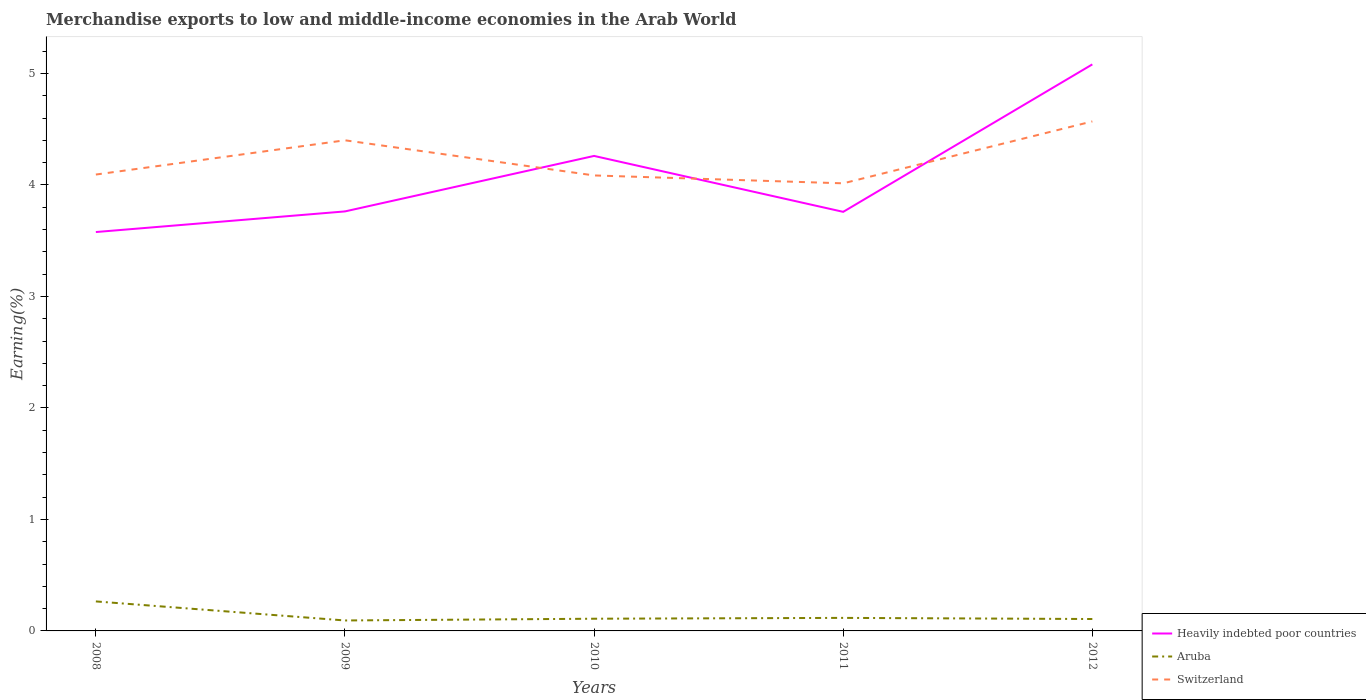How many different coloured lines are there?
Your response must be concise. 3. Is the number of lines equal to the number of legend labels?
Make the answer very short. Yes. Across all years, what is the maximum percentage of amount earned from merchandise exports in Switzerland?
Provide a succinct answer. 4.01. In which year was the percentage of amount earned from merchandise exports in Switzerland maximum?
Ensure brevity in your answer.  2011. What is the total percentage of amount earned from merchandise exports in Aruba in the graph?
Provide a succinct answer. -0.01. What is the difference between the highest and the second highest percentage of amount earned from merchandise exports in Heavily indebted poor countries?
Provide a succinct answer. 1.5. What is the difference between the highest and the lowest percentage of amount earned from merchandise exports in Heavily indebted poor countries?
Offer a terse response. 2. Is the percentage of amount earned from merchandise exports in Switzerland strictly greater than the percentage of amount earned from merchandise exports in Heavily indebted poor countries over the years?
Provide a short and direct response. No. How many lines are there?
Your response must be concise. 3. How many years are there in the graph?
Offer a terse response. 5. What is the difference between two consecutive major ticks on the Y-axis?
Offer a very short reply. 1. Where does the legend appear in the graph?
Provide a succinct answer. Bottom right. How many legend labels are there?
Provide a short and direct response. 3. What is the title of the graph?
Make the answer very short. Merchandise exports to low and middle-income economies in the Arab World. What is the label or title of the Y-axis?
Ensure brevity in your answer.  Earning(%). What is the Earning(%) of Heavily indebted poor countries in 2008?
Offer a very short reply. 3.58. What is the Earning(%) in Aruba in 2008?
Provide a succinct answer. 0.26. What is the Earning(%) in Switzerland in 2008?
Your answer should be very brief. 4.09. What is the Earning(%) in Heavily indebted poor countries in 2009?
Offer a terse response. 3.76. What is the Earning(%) in Aruba in 2009?
Ensure brevity in your answer.  0.09. What is the Earning(%) of Switzerland in 2009?
Provide a short and direct response. 4.4. What is the Earning(%) in Heavily indebted poor countries in 2010?
Your answer should be very brief. 4.26. What is the Earning(%) of Aruba in 2010?
Give a very brief answer. 0.11. What is the Earning(%) in Switzerland in 2010?
Give a very brief answer. 4.09. What is the Earning(%) of Heavily indebted poor countries in 2011?
Keep it short and to the point. 3.76. What is the Earning(%) in Aruba in 2011?
Give a very brief answer. 0.12. What is the Earning(%) of Switzerland in 2011?
Your response must be concise. 4.01. What is the Earning(%) in Heavily indebted poor countries in 2012?
Provide a short and direct response. 5.08. What is the Earning(%) of Aruba in 2012?
Your answer should be compact. 0.11. What is the Earning(%) in Switzerland in 2012?
Give a very brief answer. 4.57. Across all years, what is the maximum Earning(%) in Heavily indebted poor countries?
Give a very brief answer. 5.08. Across all years, what is the maximum Earning(%) of Aruba?
Provide a short and direct response. 0.26. Across all years, what is the maximum Earning(%) in Switzerland?
Give a very brief answer. 4.57. Across all years, what is the minimum Earning(%) in Heavily indebted poor countries?
Provide a short and direct response. 3.58. Across all years, what is the minimum Earning(%) in Aruba?
Your answer should be compact. 0.09. Across all years, what is the minimum Earning(%) in Switzerland?
Offer a very short reply. 4.01. What is the total Earning(%) of Heavily indebted poor countries in the graph?
Your response must be concise. 20.44. What is the total Earning(%) of Aruba in the graph?
Ensure brevity in your answer.  0.69. What is the total Earning(%) in Switzerland in the graph?
Ensure brevity in your answer.  21.16. What is the difference between the Earning(%) in Heavily indebted poor countries in 2008 and that in 2009?
Keep it short and to the point. -0.18. What is the difference between the Earning(%) in Aruba in 2008 and that in 2009?
Your answer should be compact. 0.17. What is the difference between the Earning(%) in Switzerland in 2008 and that in 2009?
Provide a short and direct response. -0.31. What is the difference between the Earning(%) in Heavily indebted poor countries in 2008 and that in 2010?
Provide a short and direct response. -0.68. What is the difference between the Earning(%) of Aruba in 2008 and that in 2010?
Your response must be concise. 0.16. What is the difference between the Earning(%) in Switzerland in 2008 and that in 2010?
Give a very brief answer. 0.01. What is the difference between the Earning(%) of Heavily indebted poor countries in 2008 and that in 2011?
Your answer should be compact. -0.18. What is the difference between the Earning(%) in Aruba in 2008 and that in 2011?
Your answer should be compact. 0.15. What is the difference between the Earning(%) of Switzerland in 2008 and that in 2011?
Your response must be concise. 0.08. What is the difference between the Earning(%) of Heavily indebted poor countries in 2008 and that in 2012?
Offer a terse response. -1.5. What is the difference between the Earning(%) of Aruba in 2008 and that in 2012?
Ensure brevity in your answer.  0.16. What is the difference between the Earning(%) in Switzerland in 2008 and that in 2012?
Offer a terse response. -0.48. What is the difference between the Earning(%) of Heavily indebted poor countries in 2009 and that in 2010?
Offer a terse response. -0.5. What is the difference between the Earning(%) in Aruba in 2009 and that in 2010?
Ensure brevity in your answer.  -0.02. What is the difference between the Earning(%) in Switzerland in 2009 and that in 2010?
Keep it short and to the point. 0.32. What is the difference between the Earning(%) in Heavily indebted poor countries in 2009 and that in 2011?
Offer a terse response. 0. What is the difference between the Earning(%) in Aruba in 2009 and that in 2011?
Ensure brevity in your answer.  -0.02. What is the difference between the Earning(%) in Switzerland in 2009 and that in 2011?
Give a very brief answer. 0.39. What is the difference between the Earning(%) in Heavily indebted poor countries in 2009 and that in 2012?
Offer a very short reply. -1.32. What is the difference between the Earning(%) of Aruba in 2009 and that in 2012?
Offer a terse response. -0.01. What is the difference between the Earning(%) of Switzerland in 2009 and that in 2012?
Offer a terse response. -0.17. What is the difference between the Earning(%) in Heavily indebted poor countries in 2010 and that in 2011?
Offer a terse response. 0.5. What is the difference between the Earning(%) of Aruba in 2010 and that in 2011?
Provide a succinct answer. -0.01. What is the difference between the Earning(%) in Switzerland in 2010 and that in 2011?
Give a very brief answer. 0.07. What is the difference between the Earning(%) of Heavily indebted poor countries in 2010 and that in 2012?
Offer a terse response. -0.82. What is the difference between the Earning(%) in Aruba in 2010 and that in 2012?
Give a very brief answer. 0. What is the difference between the Earning(%) of Switzerland in 2010 and that in 2012?
Your answer should be very brief. -0.48. What is the difference between the Earning(%) of Heavily indebted poor countries in 2011 and that in 2012?
Provide a succinct answer. -1.32. What is the difference between the Earning(%) of Aruba in 2011 and that in 2012?
Keep it short and to the point. 0.01. What is the difference between the Earning(%) in Switzerland in 2011 and that in 2012?
Your answer should be very brief. -0.56. What is the difference between the Earning(%) in Heavily indebted poor countries in 2008 and the Earning(%) in Aruba in 2009?
Provide a succinct answer. 3.48. What is the difference between the Earning(%) of Heavily indebted poor countries in 2008 and the Earning(%) of Switzerland in 2009?
Provide a short and direct response. -0.82. What is the difference between the Earning(%) in Aruba in 2008 and the Earning(%) in Switzerland in 2009?
Your response must be concise. -4.14. What is the difference between the Earning(%) of Heavily indebted poor countries in 2008 and the Earning(%) of Aruba in 2010?
Offer a very short reply. 3.47. What is the difference between the Earning(%) in Heavily indebted poor countries in 2008 and the Earning(%) in Switzerland in 2010?
Provide a succinct answer. -0.51. What is the difference between the Earning(%) of Aruba in 2008 and the Earning(%) of Switzerland in 2010?
Provide a succinct answer. -3.82. What is the difference between the Earning(%) of Heavily indebted poor countries in 2008 and the Earning(%) of Aruba in 2011?
Keep it short and to the point. 3.46. What is the difference between the Earning(%) in Heavily indebted poor countries in 2008 and the Earning(%) in Switzerland in 2011?
Offer a very short reply. -0.44. What is the difference between the Earning(%) of Aruba in 2008 and the Earning(%) of Switzerland in 2011?
Provide a succinct answer. -3.75. What is the difference between the Earning(%) in Heavily indebted poor countries in 2008 and the Earning(%) in Aruba in 2012?
Your response must be concise. 3.47. What is the difference between the Earning(%) in Heavily indebted poor countries in 2008 and the Earning(%) in Switzerland in 2012?
Keep it short and to the point. -0.99. What is the difference between the Earning(%) in Aruba in 2008 and the Earning(%) in Switzerland in 2012?
Provide a succinct answer. -4.3. What is the difference between the Earning(%) of Heavily indebted poor countries in 2009 and the Earning(%) of Aruba in 2010?
Provide a succinct answer. 3.65. What is the difference between the Earning(%) in Heavily indebted poor countries in 2009 and the Earning(%) in Switzerland in 2010?
Your response must be concise. -0.32. What is the difference between the Earning(%) of Aruba in 2009 and the Earning(%) of Switzerland in 2010?
Provide a succinct answer. -3.99. What is the difference between the Earning(%) in Heavily indebted poor countries in 2009 and the Earning(%) in Aruba in 2011?
Your answer should be very brief. 3.65. What is the difference between the Earning(%) in Heavily indebted poor countries in 2009 and the Earning(%) in Switzerland in 2011?
Ensure brevity in your answer.  -0.25. What is the difference between the Earning(%) of Aruba in 2009 and the Earning(%) of Switzerland in 2011?
Ensure brevity in your answer.  -3.92. What is the difference between the Earning(%) of Heavily indebted poor countries in 2009 and the Earning(%) of Aruba in 2012?
Your response must be concise. 3.66. What is the difference between the Earning(%) in Heavily indebted poor countries in 2009 and the Earning(%) in Switzerland in 2012?
Your answer should be very brief. -0.81. What is the difference between the Earning(%) in Aruba in 2009 and the Earning(%) in Switzerland in 2012?
Provide a succinct answer. -4.48. What is the difference between the Earning(%) of Heavily indebted poor countries in 2010 and the Earning(%) of Aruba in 2011?
Your answer should be compact. 4.14. What is the difference between the Earning(%) of Heavily indebted poor countries in 2010 and the Earning(%) of Switzerland in 2011?
Your answer should be very brief. 0.25. What is the difference between the Earning(%) in Aruba in 2010 and the Earning(%) in Switzerland in 2011?
Ensure brevity in your answer.  -3.9. What is the difference between the Earning(%) of Heavily indebted poor countries in 2010 and the Earning(%) of Aruba in 2012?
Make the answer very short. 4.15. What is the difference between the Earning(%) of Heavily indebted poor countries in 2010 and the Earning(%) of Switzerland in 2012?
Your answer should be very brief. -0.31. What is the difference between the Earning(%) in Aruba in 2010 and the Earning(%) in Switzerland in 2012?
Make the answer very short. -4.46. What is the difference between the Earning(%) of Heavily indebted poor countries in 2011 and the Earning(%) of Aruba in 2012?
Your answer should be very brief. 3.65. What is the difference between the Earning(%) in Heavily indebted poor countries in 2011 and the Earning(%) in Switzerland in 2012?
Offer a terse response. -0.81. What is the difference between the Earning(%) in Aruba in 2011 and the Earning(%) in Switzerland in 2012?
Your response must be concise. -4.45. What is the average Earning(%) of Heavily indebted poor countries per year?
Ensure brevity in your answer.  4.09. What is the average Earning(%) in Aruba per year?
Give a very brief answer. 0.14. What is the average Earning(%) in Switzerland per year?
Make the answer very short. 4.23. In the year 2008, what is the difference between the Earning(%) of Heavily indebted poor countries and Earning(%) of Aruba?
Keep it short and to the point. 3.31. In the year 2008, what is the difference between the Earning(%) of Heavily indebted poor countries and Earning(%) of Switzerland?
Provide a short and direct response. -0.52. In the year 2008, what is the difference between the Earning(%) of Aruba and Earning(%) of Switzerland?
Your answer should be compact. -3.83. In the year 2009, what is the difference between the Earning(%) in Heavily indebted poor countries and Earning(%) in Aruba?
Provide a succinct answer. 3.67. In the year 2009, what is the difference between the Earning(%) of Heavily indebted poor countries and Earning(%) of Switzerland?
Keep it short and to the point. -0.64. In the year 2009, what is the difference between the Earning(%) of Aruba and Earning(%) of Switzerland?
Your answer should be compact. -4.31. In the year 2010, what is the difference between the Earning(%) of Heavily indebted poor countries and Earning(%) of Aruba?
Give a very brief answer. 4.15. In the year 2010, what is the difference between the Earning(%) in Heavily indebted poor countries and Earning(%) in Switzerland?
Your answer should be very brief. 0.17. In the year 2010, what is the difference between the Earning(%) in Aruba and Earning(%) in Switzerland?
Ensure brevity in your answer.  -3.98. In the year 2011, what is the difference between the Earning(%) of Heavily indebted poor countries and Earning(%) of Aruba?
Provide a short and direct response. 3.64. In the year 2011, what is the difference between the Earning(%) of Heavily indebted poor countries and Earning(%) of Switzerland?
Give a very brief answer. -0.26. In the year 2011, what is the difference between the Earning(%) in Aruba and Earning(%) in Switzerland?
Provide a short and direct response. -3.9. In the year 2012, what is the difference between the Earning(%) in Heavily indebted poor countries and Earning(%) in Aruba?
Offer a terse response. 4.97. In the year 2012, what is the difference between the Earning(%) in Heavily indebted poor countries and Earning(%) in Switzerland?
Your response must be concise. 0.51. In the year 2012, what is the difference between the Earning(%) of Aruba and Earning(%) of Switzerland?
Give a very brief answer. -4.46. What is the ratio of the Earning(%) of Heavily indebted poor countries in 2008 to that in 2009?
Your answer should be compact. 0.95. What is the ratio of the Earning(%) in Aruba in 2008 to that in 2009?
Keep it short and to the point. 2.82. What is the ratio of the Earning(%) of Switzerland in 2008 to that in 2009?
Provide a short and direct response. 0.93. What is the ratio of the Earning(%) of Heavily indebted poor countries in 2008 to that in 2010?
Ensure brevity in your answer.  0.84. What is the ratio of the Earning(%) of Aruba in 2008 to that in 2010?
Your response must be concise. 2.42. What is the ratio of the Earning(%) of Heavily indebted poor countries in 2008 to that in 2011?
Ensure brevity in your answer.  0.95. What is the ratio of the Earning(%) in Aruba in 2008 to that in 2011?
Your response must be concise. 2.26. What is the ratio of the Earning(%) in Switzerland in 2008 to that in 2011?
Ensure brevity in your answer.  1.02. What is the ratio of the Earning(%) in Heavily indebted poor countries in 2008 to that in 2012?
Your answer should be very brief. 0.7. What is the ratio of the Earning(%) of Aruba in 2008 to that in 2012?
Give a very brief answer. 2.48. What is the ratio of the Earning(%) of Switzerland in 2008 to that in 2012?
Your response must be concise. 0.9. What is the ratio of the Earning(%) of Heavily indebted poor countries in 2009 to that in 2010?
Ensure brevity in your answer.  0.88. What is the ratio of the Earning(%) in Switzerland in 2009 to that in 2010?
Give a very brief answer. 1.08. What is the ratio of the Earning(%) of Aruba in 2009 to that in 2011?
Provide a short and direct response. 0.8. What is the ratio of the Earning(%) in Switzerland in 2009 to that in 2011?
Offer a terse response. 1.1. What is the ratio of the Earning(%) of Heavily indebted poor countries in 2009 to that in 2012?
Your response must be concise. 0.74. What is the ratio of the Earning(%) in Aruba in 2009 to that in 2012?
Your response must be concise. 0.88. What is the ratio of the Earning(%) in Heavily indebted poor countries in 2010 to that in 2011?
Keep it short and to the point. 1.13. What is the ratio of the Earning(%) of Aruba in 2010 to that in 2011?
Your answer should be very brief. 0.94. What is the ratio of the Earning(%) in Switzerland in 2010 to that in 2011?
Give a very brief answer. 1.02. What is the ratio of the Earning(%) in Heavily indebted poor countries in 2010 to that in 2012?
Your answer should be compact. 0.84. What is the ratio of the Earning(%) of Aruba in 2010 to that in 2012?
Your response must be concise. 1.03. What is the ratio of the Earning(%) of Switzerland in 2010 to that in 2012?
Your answer should be very brief. 0.89. What is the ratio of the Earning(%) of Heavily indebted poor countries in 2011 to that in 2012?
Provide a succinct answer. 0.74. What is the ratio of the Earning(%) of Aruba in 2011 to that in 2012?
Keep it short and to the point. 1.1. What is the ratio of the Earning(%) in Switzerland in 2011 to that in 2012?
Offer a very short reply. 0.88. What is the difference between the highest and the second highest Earning(%) in Heavily indebted poor countries?
Your answer should be very brief. 0.82. What is the difference between the highest and the second highest Earning(%) of Aruba?
Offer a terse response. 0.15. What is the difference between the highest and the second highest Earning(%) of Switzerland?
Your answer should be very brief. 0.17. What is the difference between the highest and the lowest Earning(%) of Heavily indebted poor countries?
Give a very brief answer. 1.5. What is the difference between the highest and the lowest Earning(%) of Aruba?
Offer a terse response. 0.17. What is the difference between the highest and the lowest Earning(%) of Switzerland?
Your answer should be compact. 0.56. 